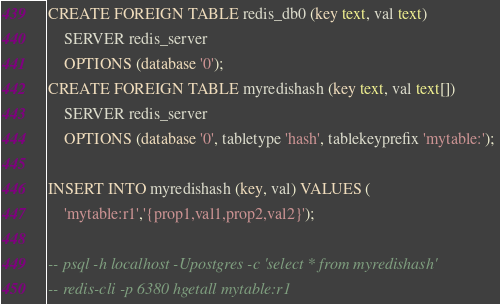<code> <loc_0><loc_0><loc_500><loc_500><_SQL_>CREATE FOREIGN TABLE redis_db0 (key text, val text)
    SERVER redis_server
    OPTIONS (database '0');
CREATE FOREIGN TABLE myredishash (key text, val text[])
    SERVER redis_server
    OPTIONS (database '0', tabletype 'hash', tablekeyprefix 'mytable:'); 

INSERT INTO myredishash (key, val) VALUES (
    'mytable:r1','{prop1,val1,prop2,val2}');

-- psql -h localhost -Upostgres -c 'select * from myredishash'
-- redis-cli -p 6380 hgetall mytable:r1
</code> 